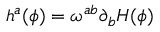<formula> <loc_0><loc_0><loc_500><loc_500>h ^ { a } ( \phi ) = \omega ^ { a b } \partial _ { b } H ( \phi )</formula> 